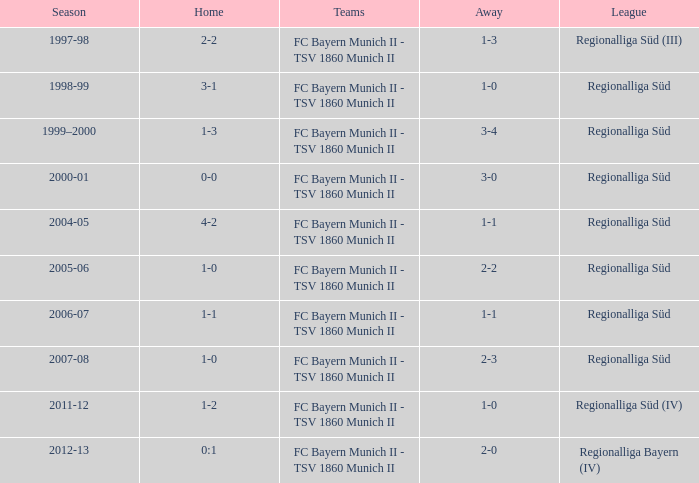What season has a regionalliga süd league, a 1-0 home, and an away of 2-3? 2007-08. 